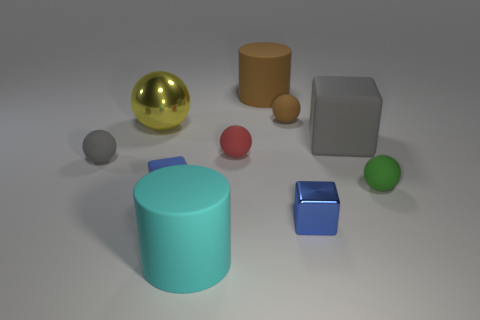There is a green rubber thing; does it have the same shape as the gray object on the left side of the yellow shiny thing?
Give a very brief answer. Yes. Are there any other things that have the same color as the metallic block?
Offer a terse response. Yes. Do the small block that is on the left side of the blue metallic object and the metallic thing right of the brown rubber ball have the same color?
Provide a succinct answer. Yes. Is there a large blue metallic sphere?
Offer a terse response. No. Are there any large cubes that have the same material as the small green object?
Provide a short and direct response. Yes. What is the color of the tiny rubber cube?
Give a very brief answer. Blue. There is a metallic thing that is the same color as the tiny rubber block; what shape is it?
Your response must be concise. Cube. The rubber block that is the same size as the green matte thing is what color?
Offer a very short reply. Blue. How many metal things are large balls or big cyan spheres?
Make the answer very short. 1. How many big things are in front of the small brown object and behind the small metal block?
Give a very brief answer. 2. 